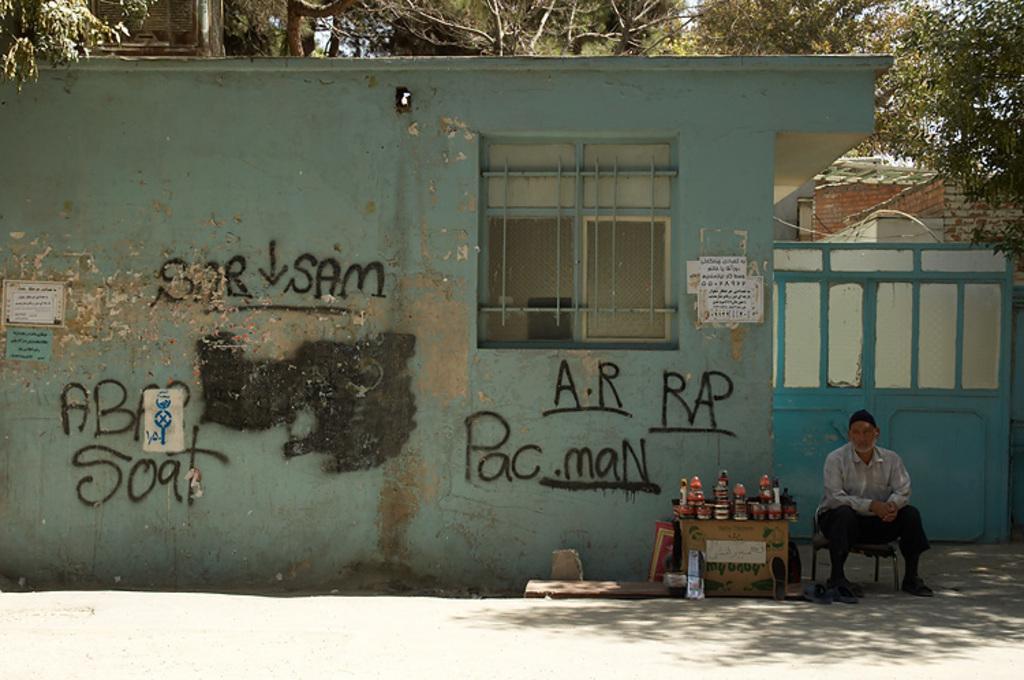Please provide a concise description of this image. In the picture we can see a person sitting on stool, next to him there are some objects on cardboard box, there is a wall on which some words are painted, there is gate and a window and in the background of the picture there are some trees. 